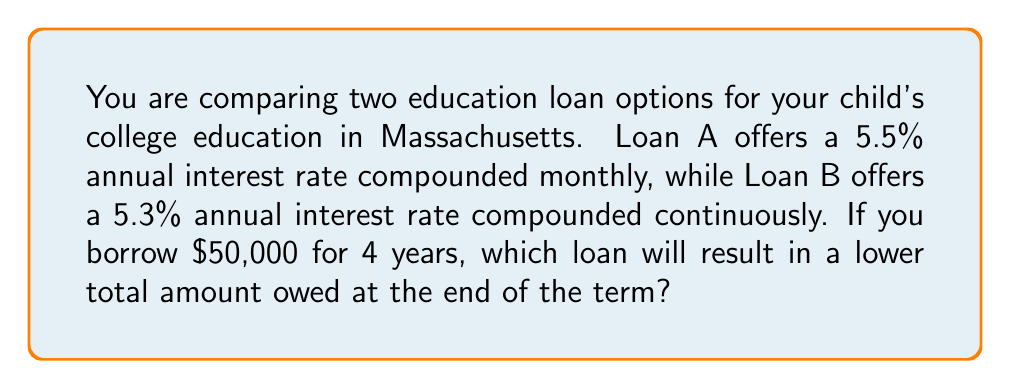Teach me how to tackle this problem. To compare the two loans, we need to calculate the total amount owed for each option after 4 years.

For Loan A (5.5% annual interest rate compounded monthly):
1. Convert the annual rate to monthly rate: $r = \frac{5.5\%}{12} = 0.458333\%$
2. Calculate the number of compounding periods: $n = 4 \times 12 = 48$ months
3. Use the compound interest formula: $A = P(1 + r)^n$
   Where $A$ is the final amount, $P$ is the principal, $r$ is the monthly rate, and $n$ is the number of months.
4. $A_A = 50000(1 + 0.00458333)^{48} = \$61,794.71$

For Loan B (5.3% annual interest rate compounded continuously):
1. Use the continuous compound interest formula: $A = Pe^{rt}$
   Where $A$ is the final amount, $P$ is the principal, $r$ is the annual rate, and $t$ is the time in years.
2. $A_B = 50000e^{0.053 \times 4} = \$61,772.18$

Comparing the two results:
Loan A: $61,794.71
Loan B: $61,772.18

The difference is $61,794.71 - 61,772.18 = \$22.53$
Answer: Loan B (5.3% compounded continuously) 